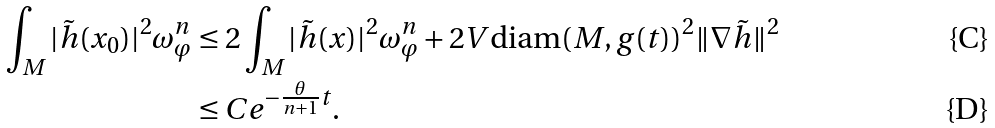<formula> <loc_0><loc_0><loc_500><loc_500>\int _ { M } | \tilde { h } ( x _ { 0 } ) | ^ { 2 } \omega ^ { n } _ { \varphi } & \leq 2 \int _ { M } | \tilde { h } ( x ) | ^ { 2 } \omega ^ { n } _ { \varphi } + 2 V \text {diam} ( M , g ( t ) ) ^ { 2 } \| \nabla \tilde { h } \| ^ { 2 } \\ & \leq C e ^ { - \frac { \theta } { n + 1 } t } .</formula> 